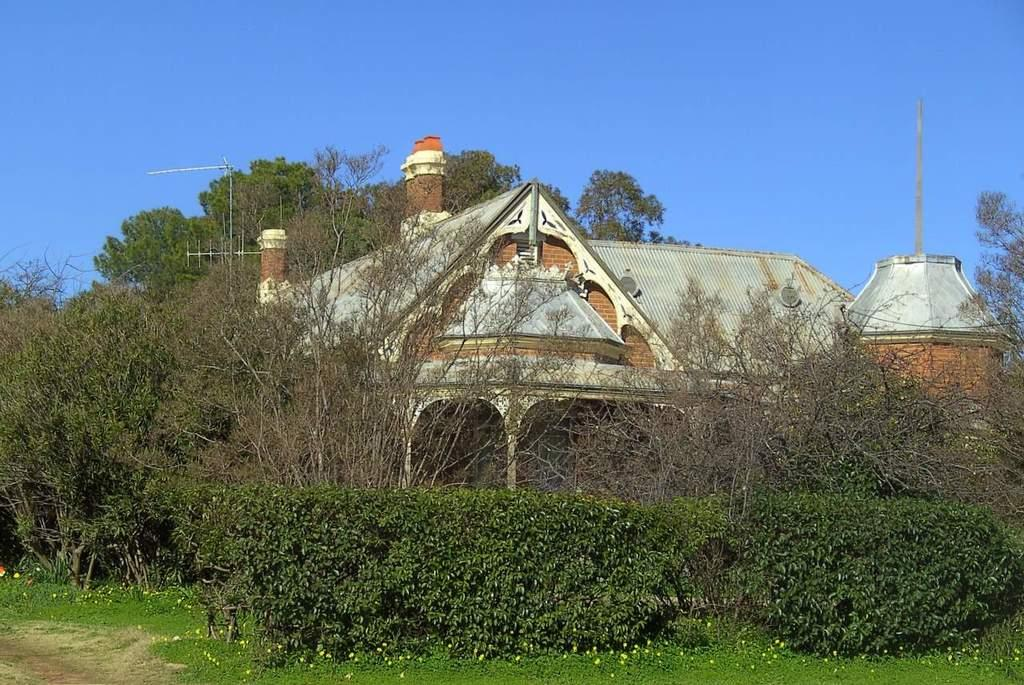What type of building is in the image? There is an old house in the image. Are there any natural elements visible in the image? Yes, there are trees around the house in the image. What color are the person's lips in the image? There is no person present in the image, so we cannot determine the color of their lips. 